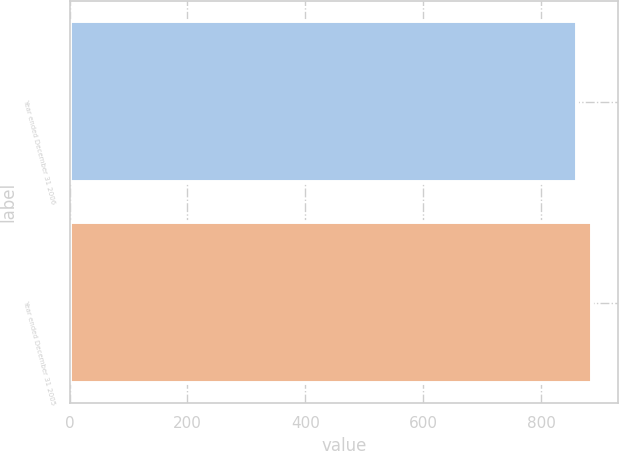Convert chart. <chart><loc_0><loc_0><loc_500><loc_500><bar_chart><fcel>Year ended December 31 2006<fcel>Year ended December 31 2005<nl><fcel>861<fcel>886<nl></chart> 